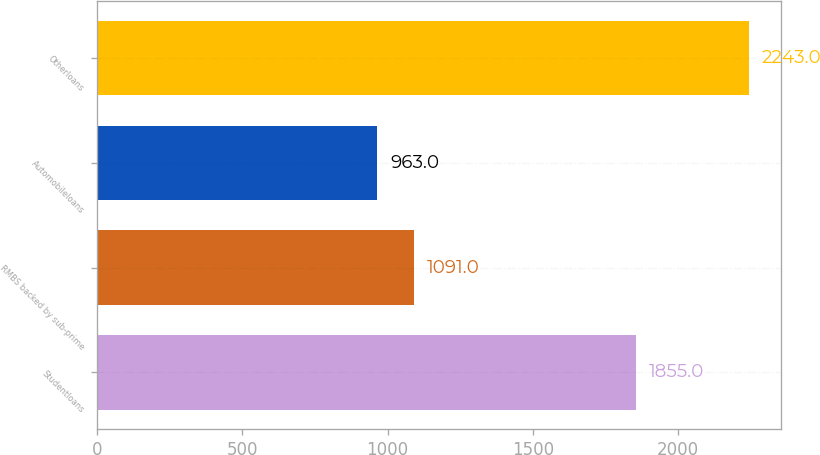Convert chart to OTSL. <chart><loc_0><loc_0><loc_500><loc_500><bar_chart><fcel>Studentloans<fcel>RMBS backed by sub-prime<fcel>Automobileloans<fcel>Otherloans<nl><fcel>1855<fcel>1091<fcel>963<fcel>2243<nl></chart> 